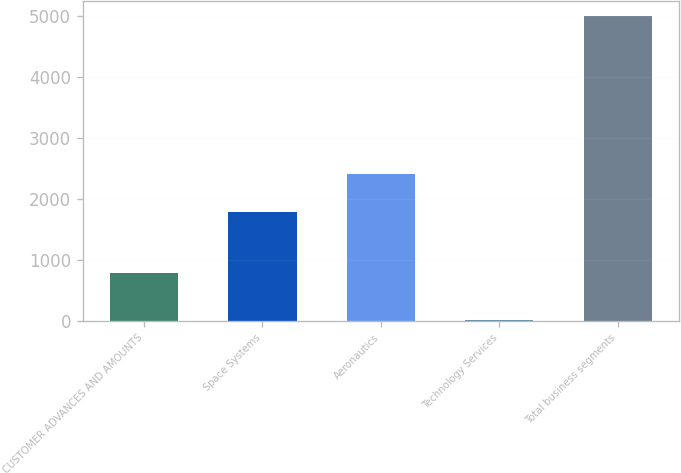Convert chart to OTSL. <chart><loc_0><loc_0><loc_500><loc_500><bar_chart><fcel>CUSTOMER ADVANCES AND AMOUNTS<fcel>Space Systems<fcel>Aeronautics<fcel>Technology Services<fcel>Total business segments<nl><fcel>797<fcel>1784<fcel>2406<fcel>15<fcel>5002<nl></chart> 